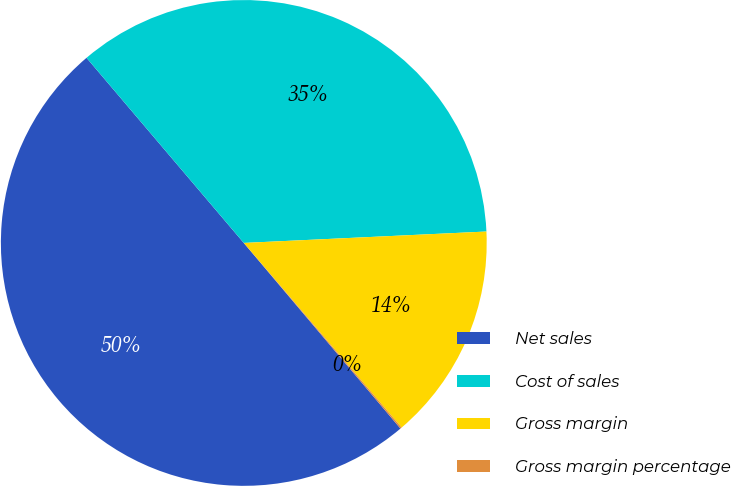Convert chart. <chart><loc_0><loc_0><loc_500><loc_500><pie_chart><fcel>Net sales<fcel>Cost of sales<fcel>Gross margin<fcel>Gross margin percentage<nl><fcel>49.95%<fcel>35.46%<fcel>14.49%<fcel>0.1%<nl></chart> 